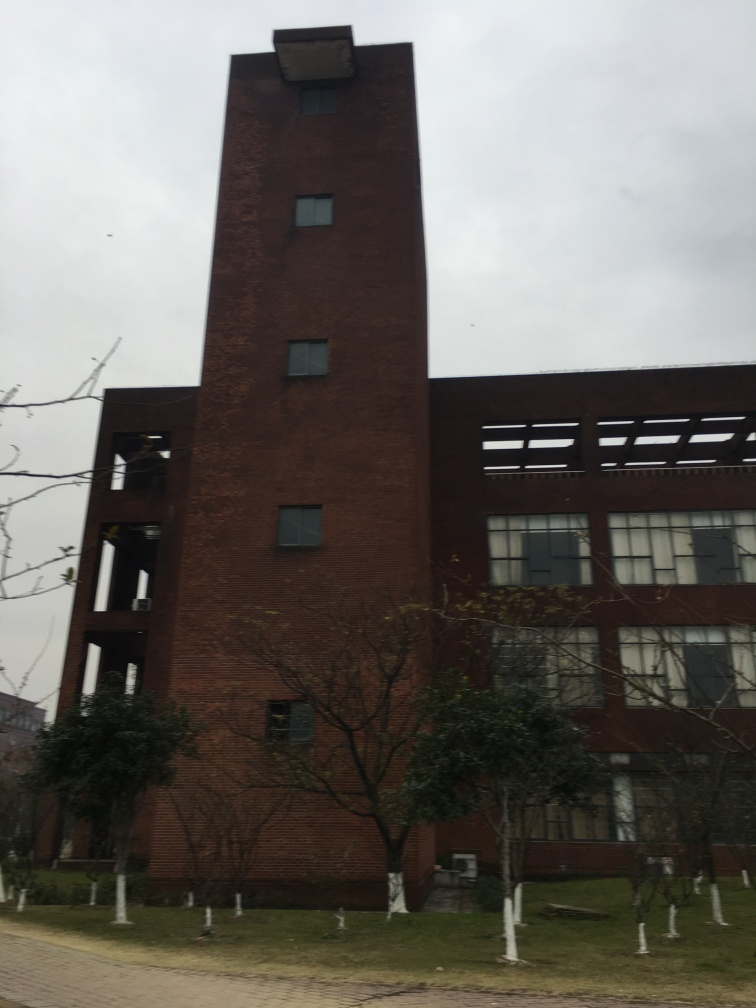What architectural style does the building in the photo represent? The building exhibits characteristics of industrial architecture, with its red brick facade and minimal ornamentation. The utilitarian design and large windows suggest a form follows function approach, common in factory or warehouse buildings transformed for other uses. 